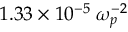Convert formula to latex. <formula><loc_0><loc_0><loc_500><loc_500>1 . 3 3 \times 1 0 ^ { - 5 } \, \omega _ { p } ^ { - 2 }</formula> 